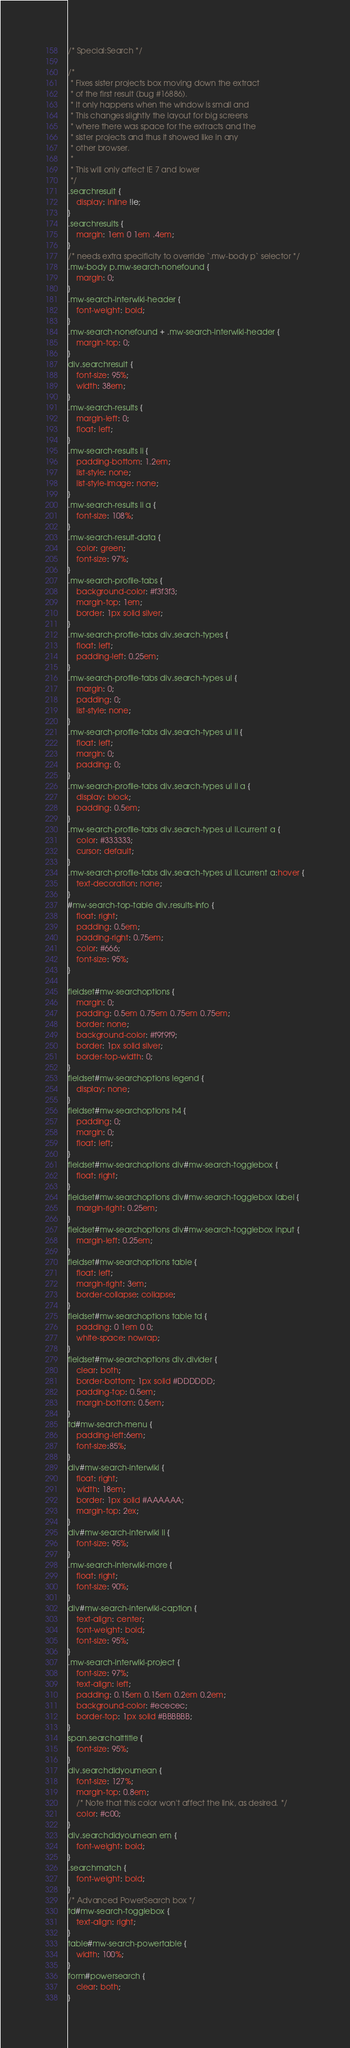<code> <loc_0><loc_0><loc_500><loc_500><_CSS_>/* Special:Search */

/*
 * Fixes sister projects box moving down the extract
 * of the first result (bug #16886).
 * It only happens when the window is small and
 * This changes slightly the layout for big screens
 * where there was space for the extracts and the
 * sister projects and thus it showed like in any
 * other browser.
 *
 * This will only affect IE 7 and lower
 */
.searchresult {
	display: inline !ie;
}
.searchresults {
	margin: 1em 0 1em .4em;
}
/* needs extra specificity to override `.mw-body p` selector */
.mw-body p.mw-search-nonefound {
	margin: 0;
}
.mw-search-interwiki-header {
	font-weight: bold;
}
.mw-search-nonefound + .mw-search-interwiki-header {
	margin-top: 0;
}
div.searchresult {
	font-size: 95%;
	width: 38em;
}
.mw-search-results {
	margin-left: 0;
	float: left;
}
.mw-search-results li {
	padding-bottom: 1.2em;
	list-style: none;
	list-style-image: none;
}
.mw-search-results li a {
	font-size: 108%;
}
.mw-search-result-data {
	color: green;
	font-size: 97%;
}
.mw-search-profile-tabs {
	background-color: #f3f3f3;
	margin-top: 1em;
	border: 1px solid silver;
}
.mw-search-profile-tabs div.search-types {
	float: left;
	padding-left: 0.25em;
}
.mw-search-profile-tabs div.search-types ul {
	margin: 0;
	padding: 0;
	list-style: none;
}
.mw-search-profile-tabs div.search-types ul li {
	float: left;
	margin: 0;
	padding: 0;
}
.mw-search-profile-tabs div.search-types ul li a {
	display: block;
	padding: 0.5em;
}
.mw-search-profile-tabs div.search-types ul li.current a {
	color: #333333;
	cursor: default;
}
.mw-search-profile-tabs div.search-types ul li.current a:hover {
	text-decoration: none;
}
#mw-search-top-table div.results-info {
	float: right;
	padding: 0.5em;
	padding-right: 0.75em;
	color: #666;
	font-size: 95%;
}

fieldset#mw-searchoptions {
	margin: 0;
	padding: 0.5em 0.75em 0.75em 0.75em;
	border: none;
	background-color: #f9f9f9;
	border: 1px solid silver;
	border-top-width: 0;
}
fieldset#mw-searchoptions legend {
	display: none;
}
fieldset#mw-searchoptions h4 {
	padding: 0;
	margin: 0;
	float: left;
}
fieldset#mw-searchoptions div#mw-search-togglebox {
	float: right;
}
fieldset#mw-searchoptions div#mw-search-togglebox label {
	margin-right: 0.25em;
}
fieldset#mw-searchoptions div#mw-search-togglebox input {
	margin-left: 0.25em;
}
fieldset#mw-searchoptions table {
	float: left;
	margin-right: 3em;
	border-collapse: collapse;
}
fieldset#mw-searchoptions table td {
	padding: 0 1em 0 0;
	white-space: nowrap;
}
fieldset#mw-searchoptions div.divider {
	clear: both;
	border-bottom: 1px solid #DDDDDD;
	padding-top: 0.5em;
	margin-bottom: 0.5em;
}
td#mw-search-menu {
	padding-left:6em;
	font-size:85%;
}
div#mw-search-interwiki {
	float: right;
	width: 18em;
	border: 1px solid #AAAAAA;
	margin-top: 2ex;
}
div#mw-search-interwiki li {
	font-size: 95%;
}
.mw-search-interwiki-more {
	float: right;
	font-size: 90%;
}
div#mw-search-interwiki-caption {
	text-align: center;
	font-weight: bold;
	font-size: 95%;
}
.mw-search-interwiki-project {
	font-size: 97%;
	text-align: left;
	padding: 0.15em 0.15em 0.2em 0.2em;
	background-color: #ececec;
	border-top: 1px solid #BBBBBB;
}
span.searchalttitle {
	font-size: 95%;
}
div.searchdidyoumean {
	font-size: 127%;
	margin-top: 0.8em;
	/* Note that this color won't affect the link, as desired. */
	color: #c00;
}
div.searchdidyoumean em {
	font-weight: bold;
}
.searchmatch {
	font-weight: bold;
}
/* Advanced PowerSearch box */
td#mw-search-togglebox {
	text-align: right;
}
table#mw-search-powertable {
	width: 100%;
}
form#powersearch {
	clear: both;
}
</code> 